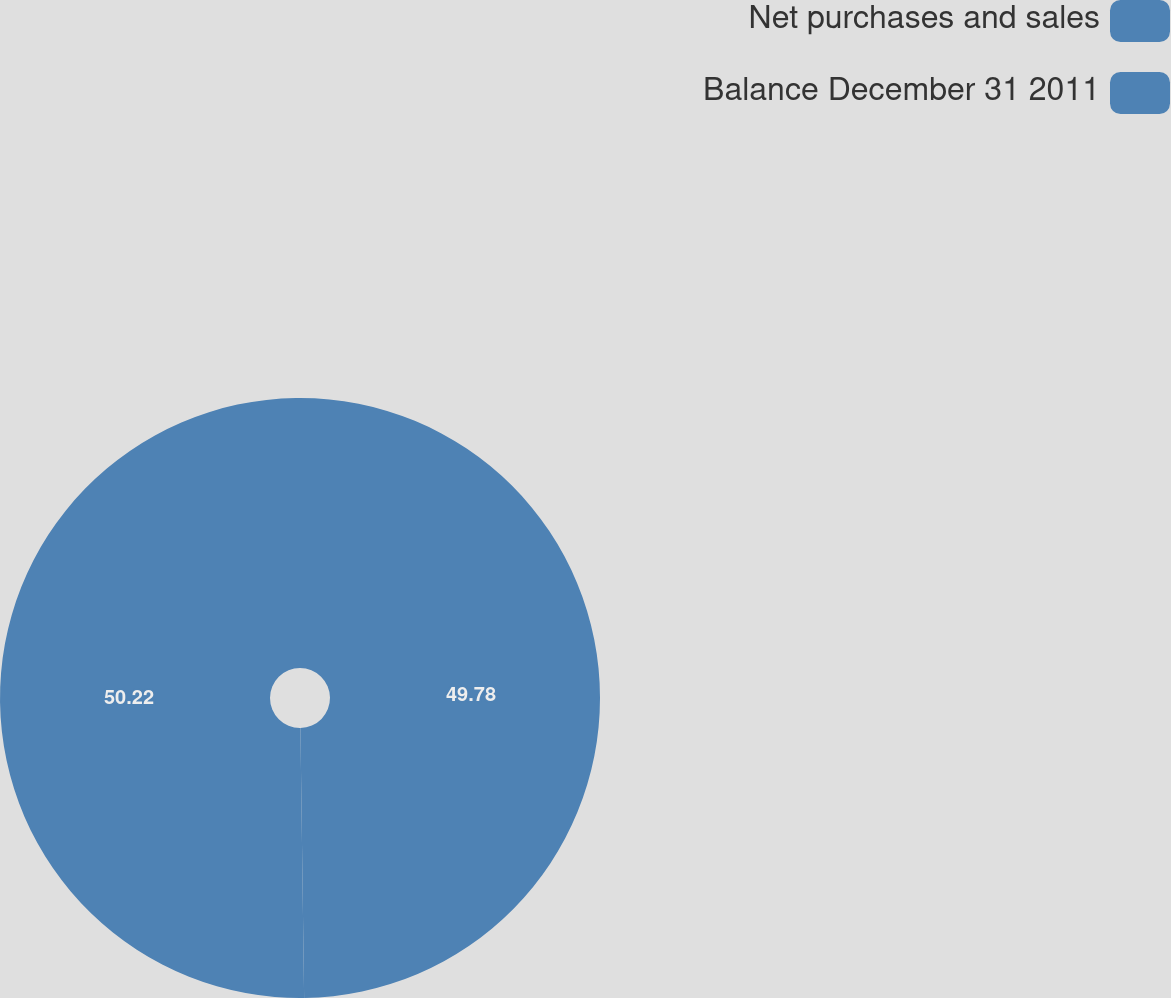Convert chart. <chart><loc_0><loc_0><loc_500><loc_500><pie_chart><fcel>Net purchases and sales<fcel>Balance December 31 2011<nl><fcel>49.78%<fcel>50.22%<nl></chart> 